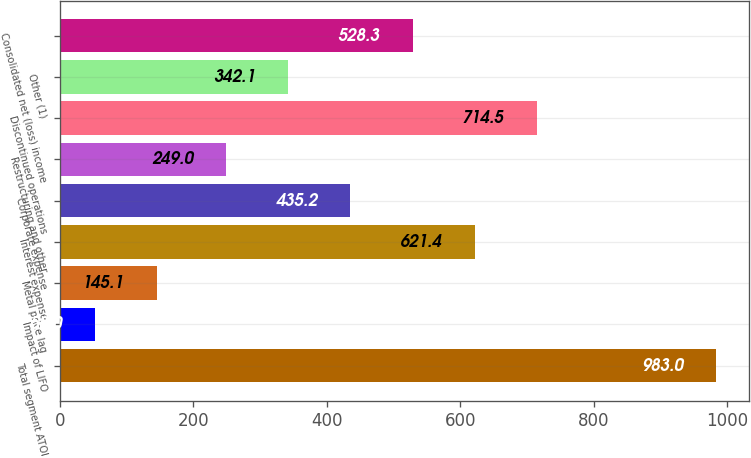Convert chart. <chart><loc_0><loc_0><loc_500><loc_500><bar_chart><fcel>Total segment ATOI<fcel>Impact of LIFO<fcel>Metal price lag<fcel>Interest expense<fcel>Corporate expense<fcel>Restructuring and other<fcel>Discontinued operations<fcel>Other (1)<fcel>Consolidated net (loss) income<nl><fcel>983<fcel>52<fcel>145.1<fcel>621.4<fcel>435.2<fcel>249<fcel>714.5<fcel>342.1<fcel>528.3<nl></chart> 